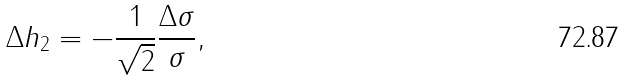<formula> <loc_0><loc_0><loc_500><loc_500>\Delta h _ { 2 } = - \frac { 1 } { \sqrt { 2 } } \frac { \Delta \sigma } { \sigma } ,</formula> 